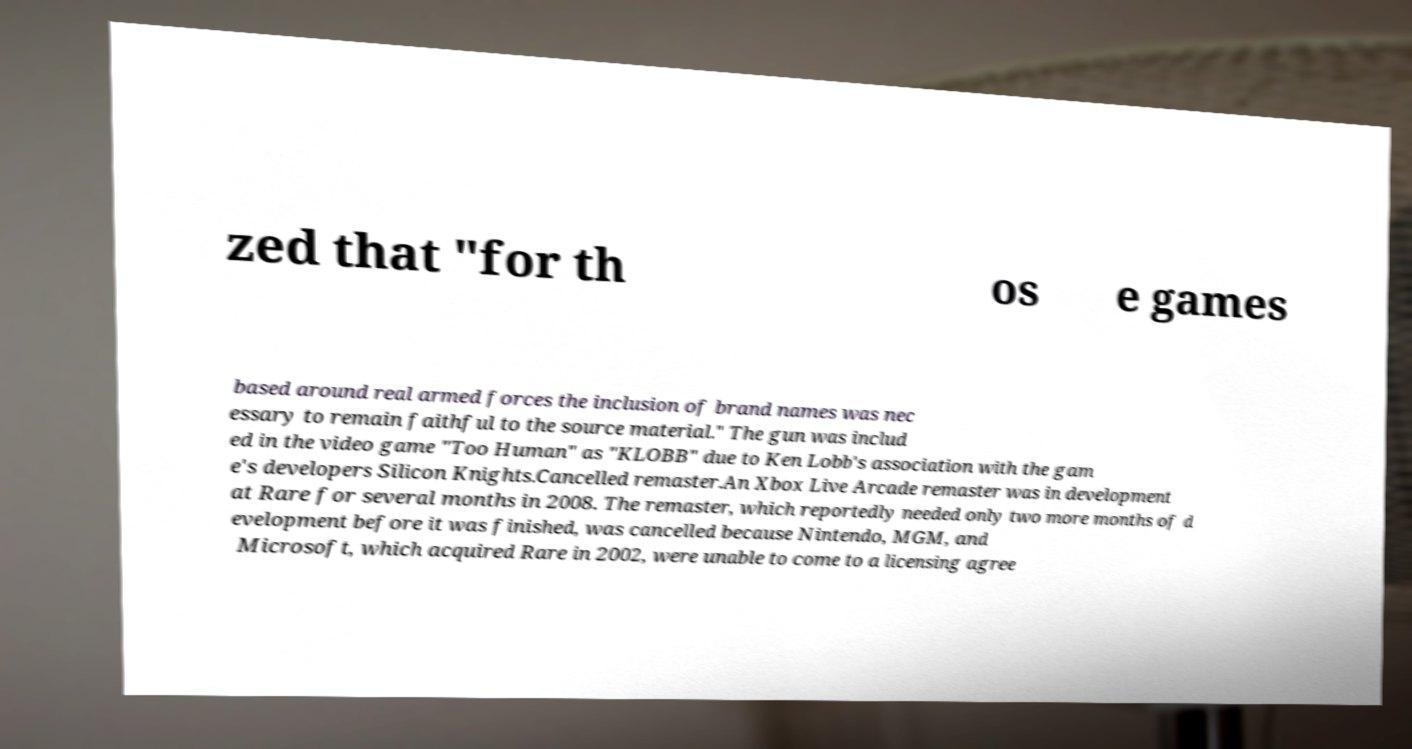Please identify and transcribe the text found in this image. zed that "for th os e games based around real armed forces the inclusion of brand names was nec essary to remain faithful to the source material." The gun was includ ed in the video game "Too Human" as "KLOBB" due to Ken Lobb's association with the gam e's developers Silicon Knights.Cancelled remaster.An Xbox Live Arcade remaster was in development at Rare for several months in 2008. The remaster, which reportedly needed only two more months of d evelopment before it was finished, was cancelled because Nintendo, MGM, and Microsoft, which acquired Rare in 2002, were unable to come to a licensing agree 